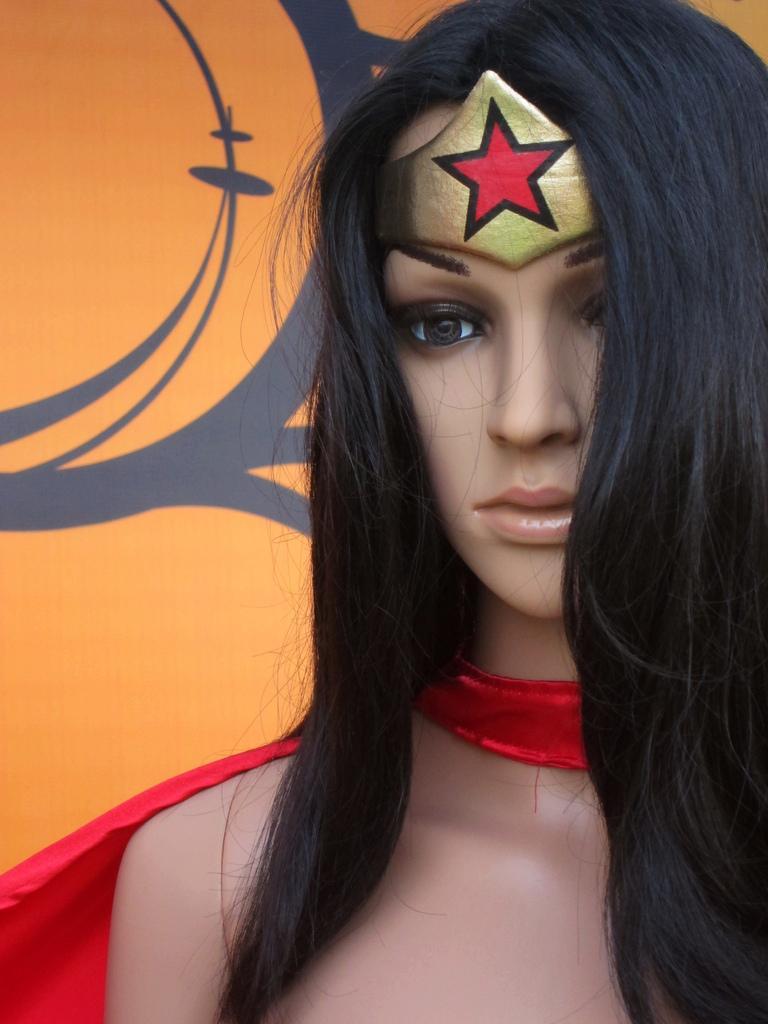In one or two sentences, can you explain what this image depicts? In this picture, we can see a lady toy in a costume, we can see the background with some art. 